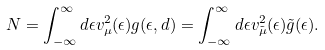Convert formula to latex. <formula><loc_0><loc_0><loc_500><loc_500>N = \int _ { - \infty } ^ { \infty } d \epsilon v ^ { 2 } _ { \mu } ( \epsilon ) g ( \epsilon , { d } ) = \int _ { - \infty } ^ { \infty } d \epsilon v ^ { 2 } _ { \tilde { \mu } } ( \epsilon ) \tilde { g } ( \epsilon ) .</formula> 